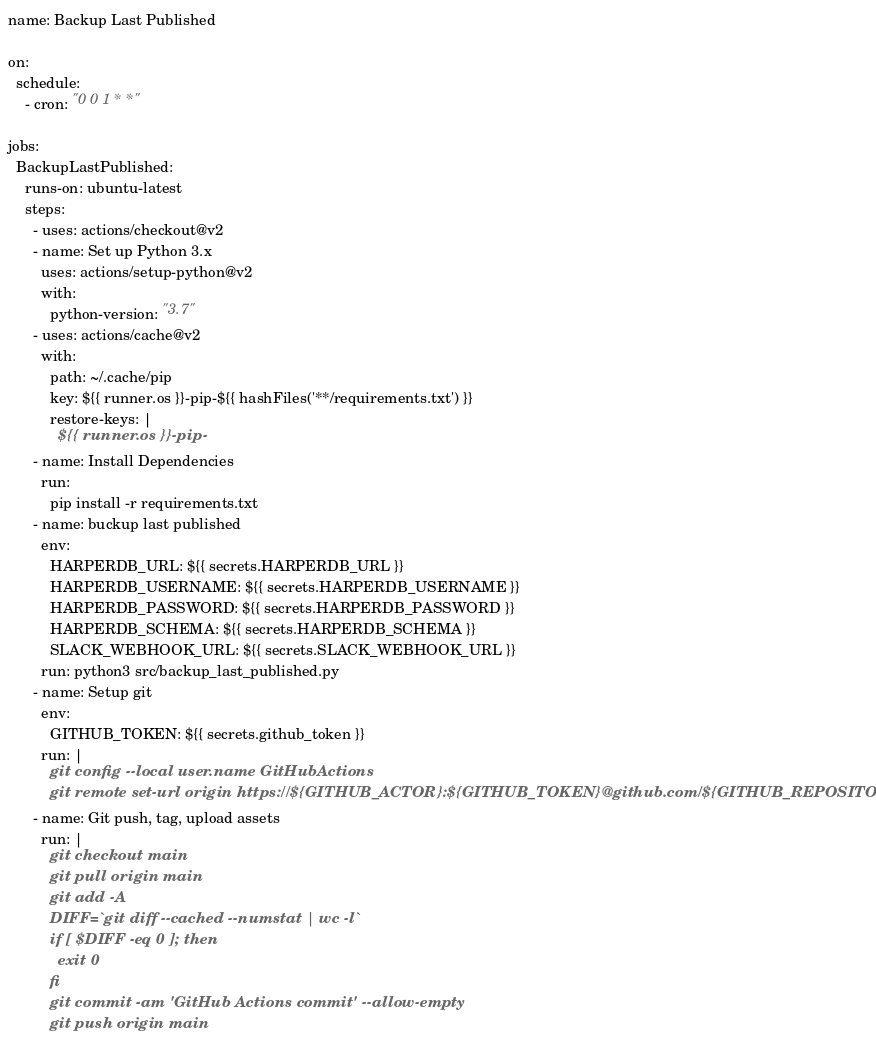<code> <loc_0><loc_0><loc_500><loc_500><_YAML_>name: Backup Last Published

on:
  schedule:
    - cron: "0 0 1 * *"

jobs:
  BackupLastPublished:
    runs-on: ubuntu-latest
    steps:
      - uses: actions/checkout@v2
      - name: Set up Python 3.x
        uses: actions/setup-python@v2
        with:
          python-version: "3.7"
      - uses: actions/cache@v2
        with:
          path: ~/.cache/pip
          key: ${{ runner.os }}-pip-${{ hashFiles('**/requirements.txt') }}
          restore-keys: |
            ${{ runner.os }}-pip-
      - name: Install Dependencies
        run:
          pip install -r requirements.txt
      - name: buckup last published
        env:
          HARPERDB_URL: ${{ secrets.HARPERDB_URL }}
          HARPERDB_USERNAME: ${{ secrets.HARPERDB_USERNAME }}
          HARPERDB_PASSWORD: ${{ secrets.HARPERDB_PASSWORD }}
          HARPERDB_SCHEMA: ${{ secrets.HARPERDB_SCHEMA }}
          SLACK_WEBHOOK_URL: ${{ secrets.SLACK_WEBHOOK_URL }}
        run: python3 src/backup_last_published.py
      - name: Setup git
        env:
          GITHUB_TOKEN: ${{ secrets.github_token }}
        run: |
          git config --local user.name GitHubActions
          git remote set-url origin https://${GITHUB_ACTOR}:${GITHUB_TOKEN}@github.com/${GITHUB_REPOSITORY}.git
      - name: Git push, tag, upload assets
        run: |
          git checkout main
          git pull origin main
          git add -A
          DIFF=`git diff --cached --numstat | wc -l`
          if [ $DIFF -eq 0 ]; then
            exit 0
          fi
          git commit -am 'GitHub Actions commit' --allow-empty
          git push origin main</code> 